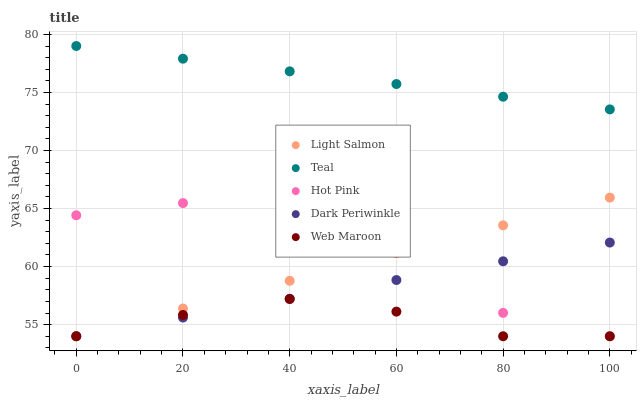Does Web Maroon have the minimum area under the curve?
Answer yes or no. Yes. Does Teal have the maximum area under the curve?
Answer yes or no. Yes. Does Hot Pink have the minimum area under the curve?
Answer yes or no. No. Does Hot Pink have the maximum area under the curve?
Answer yes or no. No. Is Dark Periwinkle the smoothest?
Answer yes or no. Yes. Is Hot Pink the roughest?
Answer yes or no. Yes. Is Web Maroon the smoothest?
Answer yes or no. No. Is Web Maroon the roughest?
Answer yes or no. No. Does Light Salmon have the lowest value?
Answer yes or no. Yes. Does Teal have the lowest value?
Answer yes or no. No. Does Teal have the highest value?
Answer yes or no. Yes. Does Hot Pink have the highest value?
Answer yes or no. No. Is Dark Periwinkle less than Teal?
Answer yes or no. Yes. Is Teal greater than Web Maroon?
Answer yes or no. Yes. Does Web Maroon intersect Dark Periwinkle?
Answer yes or no. Yes. Is Web Maroon less than Dark Periwinkle?
Answer yes or no. No. Is Web Maroon greater than Dark Periwinkle?
Answer yes or no. No. Does Dark Periwinkle intersect Teal?
Answer yes or no. No. 